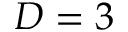Convert formula to latex. <formula><loc_0><loc_0><loc_500><loc_500>D = 3</formula> 